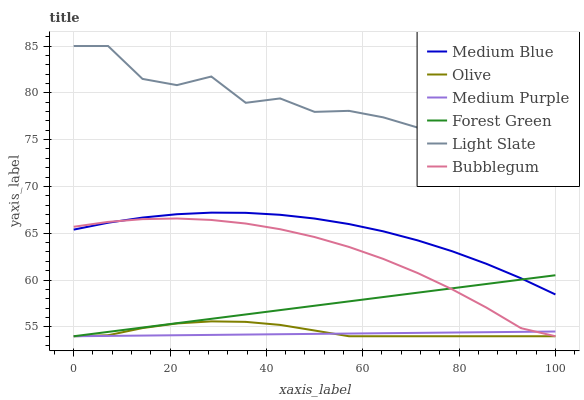Does Medium Purple have the minimum area under the curve?
Answer yes or no. Yes. Does Light Slate have the maximum area under the curve?
Answer yes or no. Yes. Does Medium Blue have the minimum area under the curve?
Answer yes or no. No. Does Medium Blue have the maximum area under the curve?
Answer yes or no. No. Is Medium Purple the smoothest?
Answer yes or no. Yes. Is Light Slate the roughest?
Answer yes or no. Yes. Is Medium Blue the smoothest?
Answer yes or no. No. Is Medium Blue the roughest?
Answer yes or no. No. Does Bubblegum have the lowest value?
Answer yes or no. Yes. Does Medium Blue have the lowest value?
Answer yes or no. No. Does Light Slate have the highest value?
Answer yes or no. Yes. Does Medium Blue have the highest value?
Answer yes or no. No. Is Olive less than Medium Blue?
Answer yes or no. Yes. Is Light Slate greater than Medium Blue?
Answer yes or no. Yes. Does Medium Purple intersect Olive?
Answer yes or no. Yes. Is Medium Purple less than Olive?
Answer yes or no. No. Is Medium Purple greater than Olive?
Answer yes or no. No. Does Olive intersect Medium Blue?
Answer yes or no. No. 